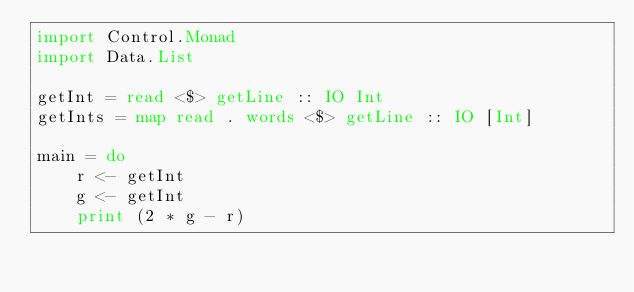<code> <loc_0><loc_0><loc_500><loc_500><_Haskell_>import Control.Monad
import Data.List

getInt = read <$> getLine :: IO Int
getInts = map read . words <$> getLine :: IO [Int]

main = do
    r <- getInt
    g <- getInt
    print (2 * g - r)

</code> 